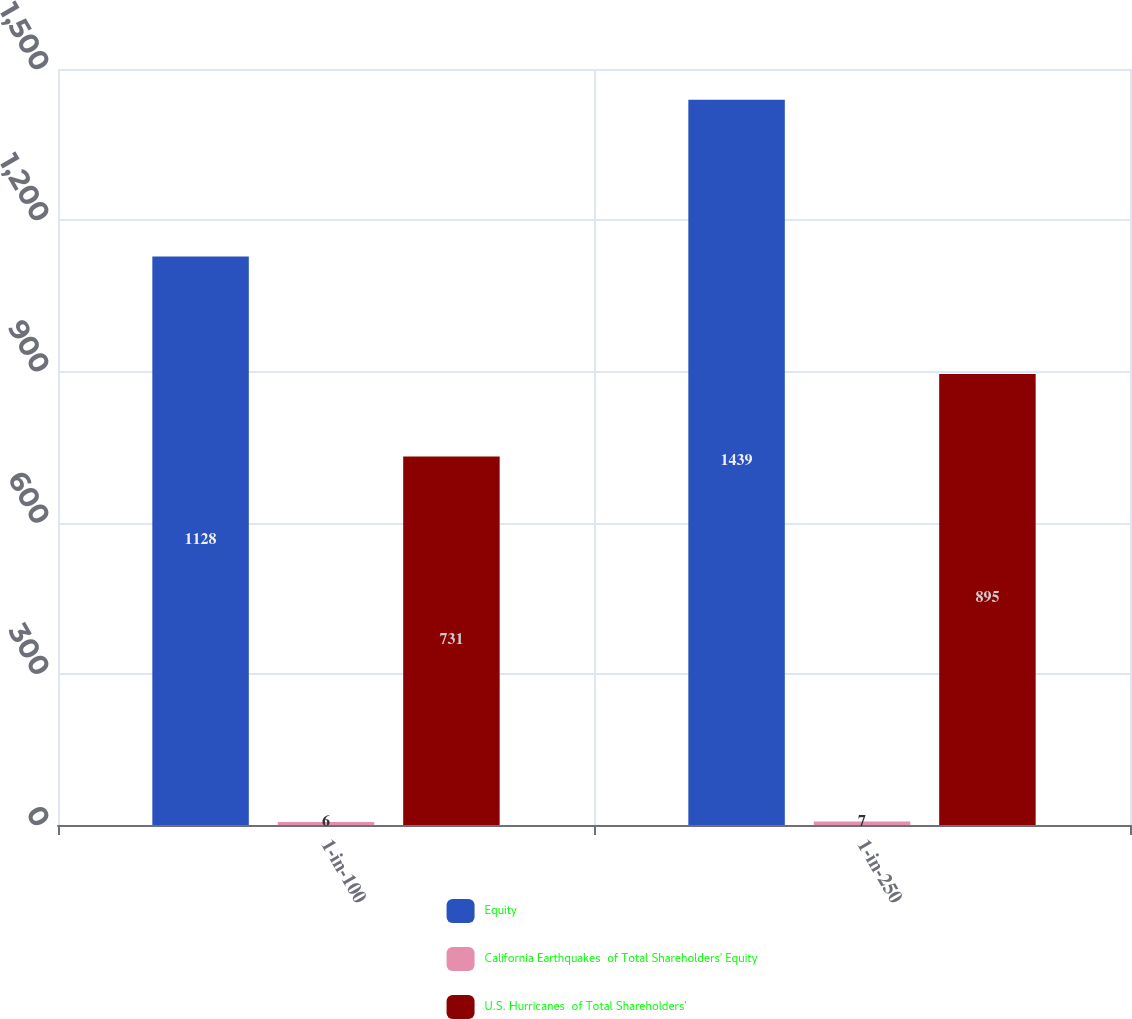Convert chart to OTSL. <chart><loc_0><loc_0><loc_500><loc_500><stacked_bar_chart><ecel><fcel>1-in-100<fcel>1-in-250<nl><fcel>Equity<fcel>1128<fcel>1439<nl><fcel>California Earthquakes  of Total Shareholders' Equity<fcel>6<fcel>7<nl><fcel>U.S. Hurricanes  of Total Shareholders'<fcel>731<fcel>895<nl></chart> 